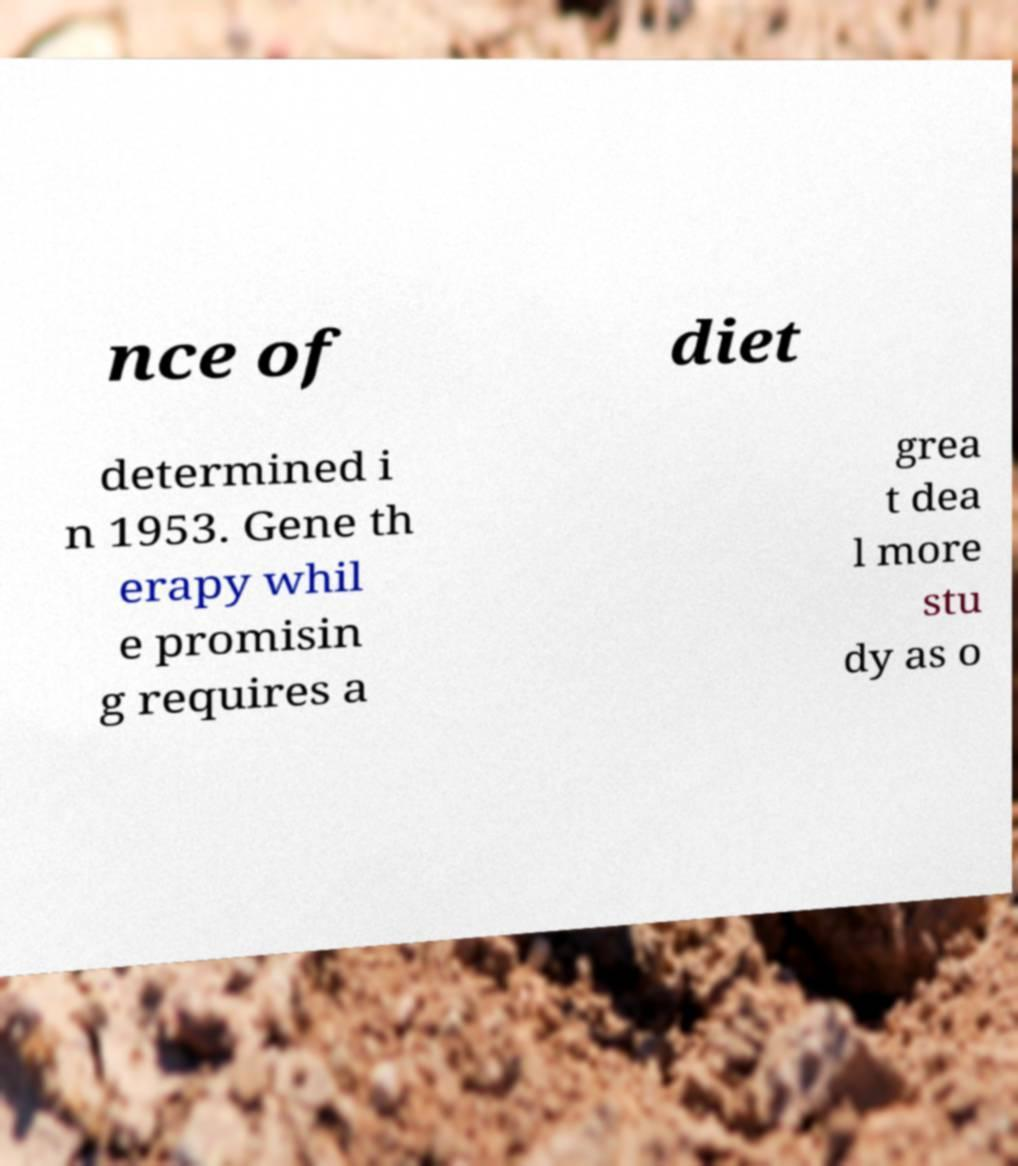Please read and relay the text visible in this image. What does it say? nce of diet determined i n 1953. Gene th erapy whil e promisin g requires a grea t dea l more stu dy as o 